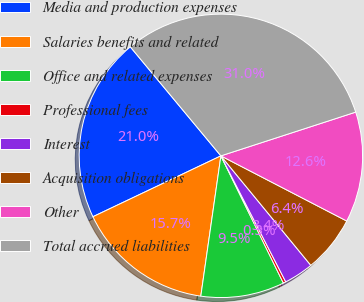<chart> <loc_0><loc_0><loc_500><loc_500><pie_chart><fcel>Media and production expenses<fcel>Salaries benefits and related<fcel>Office and related expenses<fcel>Professional fees<fcel>Interest<fcel>Acquisition obligations<fcel>Other<fcel>Total accrued liabilities<nl><fcel>21.03%<fcel>15.67%<fcel>9.53%<fcel>0.3%<fcel>3.38%<fcel>6.45%<fcel>12.6%<fcel>31.04%<nl></chart> 